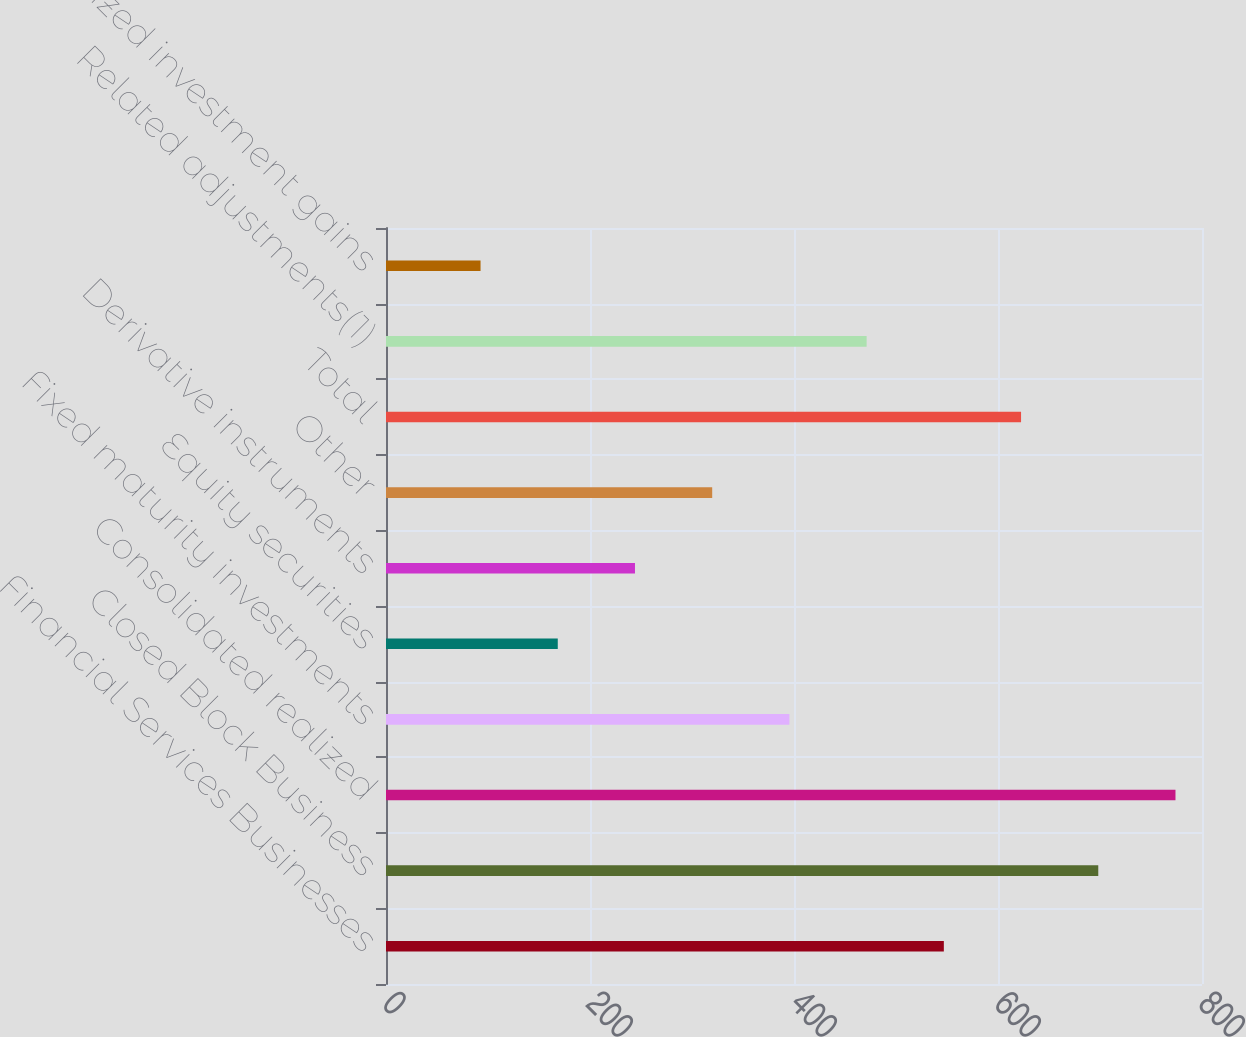Convert chart to OTSL. <chart><loc_0><loc_0><loc_500><loc_500><bar_chart><fcel>Financial Services Businesses<fcel>Closed Block Business<fcel>Consolidated realized<fcel>Fixed maturity investments<fcel>Equity securities<fcel>Derivative instruments<fcel>Other<fcel>Total<fcel>Related adjustments(1)<fcel>Realized investment gains<nl><fcel>546.9<fcel>698.3<fcel>774<fcel>395.5<fcel>168.4<fcel>244.1<fcel>319.8<fcel>622.6<fcel>471.2<fcel>92.7<nl></chart> 